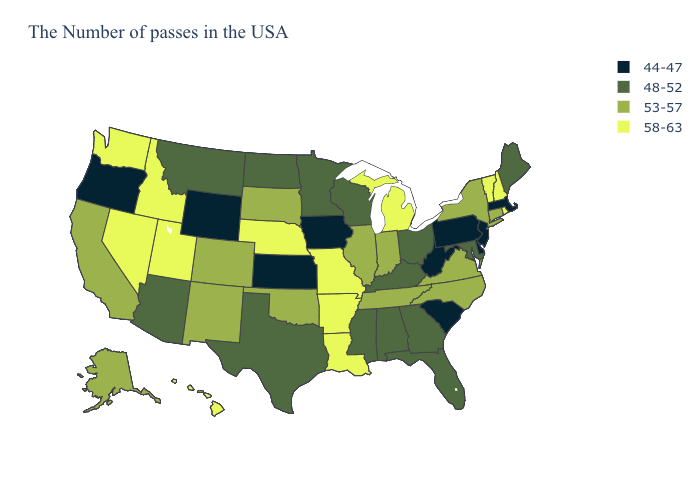What is the highest value in the USA?
Be succinct. 58-63. Among the states that border Michigan , does Indiana have the lowest value?
Keep it brief. No. Name the states that have a value in the range 44-47?
Concise answer only. Massachusetts, New Jersey, Delaware, Pennsylvania, South Carolina, West Virginia, Iowa, Kansas, Wyoming, Oregon. Does Nebraska have the highest value in the MidWest?
Answer briefly. Yes. Is the legend a continuous bar?
Write a very short answer. No. What is the value of Delaware?
Give a very brief answer. 44-47. Which states hav the highest value in the MidWest?
Give a very brief answer. Michigan, Missouri, Nebraska. What is the value of New Mexico?
Quick response, please. 53-57. Does Virginia have the highest value in the USA?
Keep it brief. No. Name the states that have a value in the range 58-63?
Be succinct. Rhode Island, New Hampshire, Vermont, Michigan, Louisiana, Missouri, Arkansas, Nebraska, Utah, Idaho, Nevada, Washington, Hawaii. Does the first symbol in the legend represent the smallest category?
Concise answer only. Yes. Name the states that have a value in the range 44-47?
Keep it brief. Massachusetts, New Jersey, Delaware, Pennsylvania, South Carolina, West Virginia, Iowa, Kansas, Wyoming, Oregon. Does Utah have the highest value in the USA?
Give a very brief answer. Yes. Is the legend a continuous bar?
Concise answer only. No. Does New Jersey have the lowest value in the Northeast?
Quick response, please. Yes. 